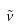<formula> <loc_0><loc_0><loc_500><loc_500>\tilde { \nu }</formula> 